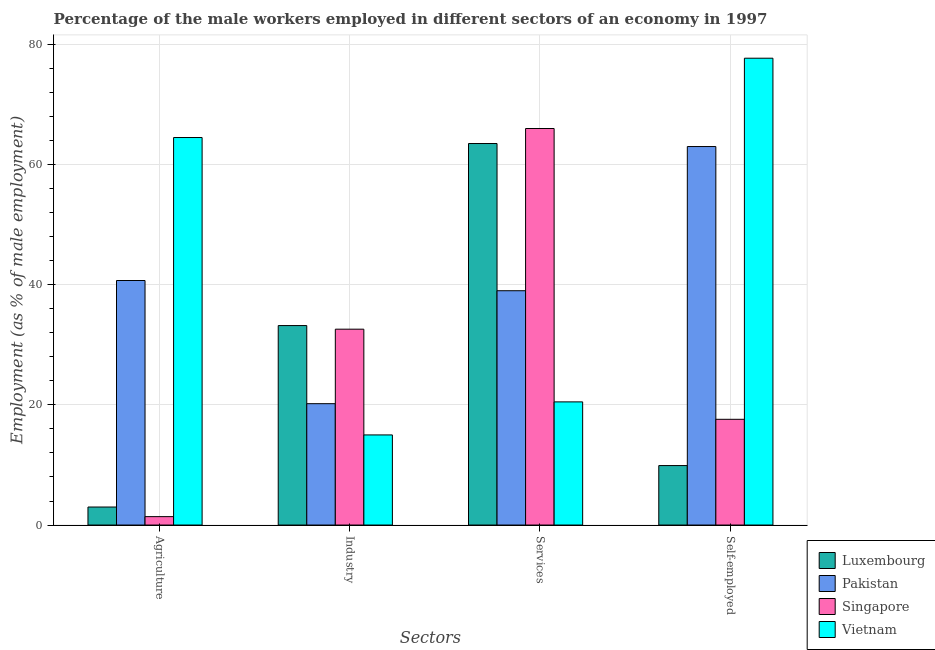How many different coloured bars are there?
Your answer should be very brief. 4. Are the number of bars on each tick of the X-axis equal?
Offer a very short reply. Yes. How many bars are there on the 3rd tick from the left?
Keep it short and to the point. 4. How many bars are there on the 1st tick from the right?
Your response must be concise. 4. What is the label of the 1st group of bars from the left?
Make the answer very short. Agriculture. Across all countries, what is the maximum percentage of male workers in agriculture?
Your answer should be very brief. 64.5. In which country was the percentage of male workers in agriculture maximum?
Offer a very short reply. Vietnam. In which country was the percentage of self employed male workers minimum?
Ensure brevity in your answer.  Luxembourg. What is the total percentage of male workers in industry in the graph?
Your answer should be compact. 101. What is the difference between the percentage of self employed male workers in Luxembourg and the percentage of male workers in services in Pakistan?
Keep it short and to the point. -29.1. What is the average percentage of male workers in services per country?
Give a very brief answer. 47.25. What is the difference between the percentage of male workers in services and percentage of male workers in agriculture in Singapore?
Provide a succinct answer. 64.6. What is the ratio of the percentage of self employed male workers in Vietnam to that in Luxembourg?
Give a very brief answer. 7.85. Is the percentage of self employed male workers in Pakistan less than that in Vietnam?
Your answer should be very brief. Yes. Is the difference between the percentage of male workers in services in Pakistan and Singapore greater than the difference between the percentage of self employed male workers in Pakistan and Singapore?
Ensure brevity in your answer.  No. What is the difference between the highest and the second highest percentage of male workers in agriculture?
Keep it short and to the point. 23.8. What is the difference between the highest and the lowest percentage of male workers in industry?
Your answer should be compact. 18.2. Is it the case that in every country, the sum of the percentage of male workers in agriculture and percentage of male workers in services is greater than the sum of percentage of male workers in industry and percentage of self employed male workers?
Your response must be concise. No. What does the 2nd bar from the left in Services represents?
Provide a succinct answer. Pakistan. What does the 1st bar from the right in Industry represents?
Offer a very short reply. Vietnam. Are all the bars in the graph horizontal?
Your answer should be compact. No. How many countries are there in the graph?
Give a very brief answer. 4. What is the difference between two consecutive major ticks on the Y-axis?
Make the answer very short. 20. Are the values on the major ticks of Y-axis written in scientific E-notation?
Provide a succinct answer. No. Does the graph contain any zero values?
Your answer should be very brief. No. Does the graph contain grids?
Offer a terse response. Yes. How many legend labels are there?
Give a very brief answer. 4. How are the legend labels stacked?
Provide a short and direct response. Vertical. What is the title of the graph?
Ensure brevity in your answer.  Percentage of the male workers employed in different sectors of an economy in 1997. What is the label or title of the X-axis?
Provide a succinct answer. Sectors. What is the label or title of the Y-axis?
Ensure brevity in your answer.  Employment (as % of male employment). What is the Employment (as % of male employment) of Luxembourg in Agriculture?
Your response must be concise. 3. What is the Employment (as % of male employment) in Pakistan in Agriculture?
Provide a succinct answer. 40.7. What is the Employment (as % of male employment) in Singapore in Agriculture?
Provide a succinct answer. 1.4. What is the Employment (as % of male employment) of Vietnam in Agriculture?
Provide a short and direct response. 64.5. What is the Employment (as % of male employment) in Luxembourg in Industry?
Your answer should be compact. 33.2. What is the Employment (as % of male employment) of Pakistan in Industry?
Offer a very short reply. 20.2. What is the Employment (as % of male employment) of Singapore in Industry?
Give a very brief answer. 32.6. What is the Employment (as % of male employment) in Vietnam in Industry?
Your response must be concise. 15. What is the Employment (as % of male employment) of Luxembourg in Services?
Offer a terse response. 63.5. What is the Employment (as % of male employment) in Pakistan in Services?
Offer a terse response. 39. What is the Employment (as % of male employment) of Vietnam in Services?
Offer a terse response. 20.5. What is the Employment (as % of male employment) of Luxembourg in Self-employed?
Keep it short and to the point. 9.9. What is the Employment (as % of male employment) of Pakistan in Self-employed?
Your answer should be very brief. 63. What is the Employment (as % of male employment) of Singapore in Self-employed?
Give a very brief answer. 17.6. What is the Employment (as % of male employment) of Vietnam in Self-employed?
Ensure brevity in your answer.  77.7. Across all Sectors, what is the maximum Employment (as % of male employment) of Luxembourg?
Make the answer very short. 63.5. Across all Sectors, what is the maximum Employment (as % of male employment) of Pakistan?
Your response must be concise. 63. Across all Sectors, what is the maximum Employment (as % of male employment) in Vietnam?
Provide a succinct answer. 77.7. Across all Sectors, what is the minimum Employment (as % of male employment) in Pakistan?
Provide a short and direct response. 20.2. Across all Sectors, what is the minimum Employment (as % of male employment) in Singapore?
Your answer should be compact. 1.4. Across all Sectors, what is the minimum Employment (as % of male employment) of Vietnam?
Provide a short and direct response. 15. What is the total Employment (as % of male employment) of Luxembourg in the graph?
Your response must be concise. 109.6. What is the total Employment (as % of male employment) in Pakistan in the graph?
Your answer should be compact. 162.9. What is the total Employment (as % of male employment) in Singapore in the graph?
Offer a very short reply. 117.6. What is the total Employment (as % of male employment) of Vietnam in the graph?
Offer a very short reply. 177.7. What is the difference between the Employment (as % of male employment) in Luxembourg in Agriculture and that in Industry?
Keep it short and to the point. -30.2. What is the difference between the Employment (as % of male employment) in Pakistan in Agriculture and that in Industry?
Your answer should be compact. 20.5. What is the difference between the Employment (as % of male employment) in Singapore in Agriculture and that in Industry?
Ensure brevity in your answer.  -31.2. What is the difference between the Employment (as % of male employment) in Vietnam in Agriculture and that in Industry?
Make the answer very short. 49.5. What is the difference between the Employment (as % of male employment) of Luxembourg in Agriculture and that in Services?
Your answer should be very brief. -60.5. What is the difference between the Employment (as % of male employment) of Pakistan in Agriculture and that in Services?
Give a very brief answer. 1.7. What is the difference between the Employment (as % of male employment) in Singapore in Agriculture and that in Services?
Give a very brief answer. -64.6. What is the difference between the Employment (as % of male employment) of Pakistan in Agriculture and that in Self-employed?
Your answer should be very brief. -22.3. What is the difference between the Employment (as % of male employment) in Singapore in Agriculture and that in Self-employed?
Your answer should be compact. -16.2. What is the difference between the Employment (as % of male employment) in Luxembourg in Industry and that in Services?
Provide a succinct answer. -30.3. What is the difference between the Employment (as % of male employment) of Pakistan in Industry and that in Services?
Provide a succinct answer. -18.8. What is the difference between the Employment (as % of male employment) in Singapore in Industry and that in Services?
Offer a very short reply. -33.4. What is the difference between the Employment (as % of male employment) in Luxembourg in Industry and that in Self-employed?
Your response must be concise. 23.3. What is the difference between the Employment (as % of male employment) in Pakistan in Industry and that in Self-employed?
Ensure brevity in your answer.  -42.8. What is the difference between the Employment (as % of male employment) in Singapore in Industry and that in Self-employed?
Offer a very short reply. 15. What is the difference between the Employment (as % of male employment) in Vietnam in Industry and that in Self-employed?
Offer a very short reply. -62.7. What is the difference between the Employment (as % of male employment) in Luxembourg in Services and that in Self-employed?
Offer a very short reply. 53.6. What is the difference between the Employment (as % of male employment) of Singapore in Services and that in Self-employed?
Provide a succinct answer. 48.4. What is the difference between the Employment (as % of male employment) of Vietnam in Services and that in Self-employed?
Provide a short and direct response. -57.2. What is the difference between the Employment (as % of male employment) in Luxembourg in Agriculture and the Employment (as % of male employment) in Pakistan in Industry?
Give a very brief answer. -17.2. What is the difference between the Employment (as % of male employment) in Luxembourg in Agriculture and the Employment (as % of male employment) in Singapore in Industry?
Your answer should be very brief. -29.6. What is the difference between the Employment (as % of male employment) of Luxembourg in Agriculture and the Employment (as % of male employment) of Vietnam in Industry?
Make the answer very short. -12. What is the difference between the Employment (as % of male employment) in Pakistan in Agriculture and the Employment (as % of male employment) in Singapore in Industry?
Keep it short and to the point. 8.1. What is the difference between the Employment (as % of male employment) of Pakistan in Agriculture and the Employment (as % of male employment) of Vietnam in Industry?
Provide a short and direct response. 25.7. What is the difference between the Employment (as % of male employment) of Singapore in Agriculture and the Employment (as % of male employment) of Vietnam in Industry?
Offer a terse response. -13.6. What is the difference between the Employment (as % of male employment) in Luxembourg in Agriculture and the Employment (as % of male employment) in Pakistan in Services?
Provide a succinct answer. -36. What is the difference between the Employment (as % of male employment) in Luxembourg in Agriculture and the Employment (as % of male employment) in Singapore in Services?
Ensure brevity in your answer.  -63. What is the difference between the Employment (as % of male employment) of Luxembourg in Agriculture and the Employment (as % of male employment) of Vietnam in Services?
Offer a very short reply. -17.5. What is the difference between the Employment (as % of male employment) of Pakistan in Agriculture and the Employment (as % of male employment) of Singapore in Services?
Keep it short and to the point. -25.3. What is the difference between the Employment (as % of male employment) in Pakistan in Agriculture and the Employment (as % of male employment) in Vietnam in Services?
Your answer should be very brief. 20.2. What is the difference between the Employment (as % of male employment) of Singapore in Agriculture and the Employment (as % of male employment) of Vietnam in Services?
Your response must be concise. -19.1. What is the difference between the Employment (as % of male employment) of Luxembourg in Agriculture and the Employment (as % of male employment) of Pakistan in Self-employed?
Offer a terse response. -60. What is the difference between the Employment (as % of male employment) in Luxembourg in Agriculture and the Employment (as % of male employment) in Singapore in Self-employed?
Your answer should be compact. -14.6. What is the difference between the Employment (as % of male employment) of Luxembourg in Agriculture and the Employment (as % of male employment) of Vietnam in Self-employed?
Your answer should be compact. -74.7. What is the difference between the Employment (as % of male employment) of Pakistan in Agriculture and the Employment (as % of male employment) of Singapore in Self-employed?
Give a very brief answer. 23.1. What is the difference between the Employment (as % of male employment) of Pakistan in Agriculture and the Employment (as % of male employment) of Vietnam in Self-employed?
Provide a succinct answer. -37. What is the difference between the Employment (as % of male employment) in Singapore in Agriculture and the Employment (as % of male employment) in Vietnam in Self-employed?
Your answer should be very brief. -76.3. What is the difference between the Employment (as % of male employment) of Luxembourg in Industry and the Employment (as % of male employment) of Pakistan in Services?
Keep it short and to the point. -5.8. What is the difference between the Employment (as % of male employment) in Luxembourg in Industry and the Employment (as % of male employment) in Singapore in Services?
Make the answer very short. -32.8. What is the difference between the Employment (as % of male employment) in Luxembourg in Industry and the Employment (as % of male employment) in Vietnam in Services?
Your answer should be very brief. 12.7. What is the difference between the Employment (as % of male employment) of Pakistan in Industry and the Employment (as % of male employment) of Singapore in Services?
Give a very brief answer. -45.8. What is the difference between the Employment (as % of male employment) of Singapore in Industry and the Employment (as % of male employment) of Vietnam in Services?
Your response must be concise. 12.1. What is the difference between the Employment (as % of male employment) of Luxembourg in Industry and the Employment (as % of male employment) of Pakistan in Self-employed?
Provide a succinct answer. -29.8. What is the difference between the Employment (as % of male employment) of Luxembourg in Industry and the Employment (as % of male employment) of Vietnam in Self-employed?
Your answer should be compact. -44.5. What is the difference between the Employment (as % of male employment) of Pakistan in Industry and the Employment (as % of male employment) of Singapore in Self-employed?
Provide a short and direct response. 2.6. What is the difference between the Employment (as % of male employment) of Pakistan in Industry and the Employment (as % of male employment) of Vietnam in Self-employed?
Offer a terse response. -57.5. What is the difference between the Employment (as % of male employment) of Singapore in Industry and the Employment (as % of male employment) of Vietnam in Self-employed?
Offer a very short reply. -45.1. What is the difference between the Employment (as % of male employment) in Luxembourg in Services and the Employment (as % of male employment) in Singapore in Self-employed?
Provide a succinct answer. 45.9. What is the difference between the Employment (as % of male employment) of Pakistan in Services and the Employment (as % of male employment) of Singapore in Self-employed?
Your response must be concise. 21.4. What is the difference between the Employment (as % of male employment) in Pakistan in Services and the Employment (as % of male employment) in Vietnam in Self-employed?
Offer a terse response. -38.7. What is the average Employment (as % of male employment) of Luxembourg per Sectors?
Give a very brief answer. 27.4. What is the average Employment (as % of male employment) of Pakistan per Sectors?
Offer a very short reply. 40.73. What is the average Employment (as % of male employment) of Singapore per Sectors?
Make the answer very short. 29.4. What is the average Employment (as % of male employment) in Vietnam per Sectors?
Provide a short and direct response. 44.42. What is the difference between the Employment (as % of male employment) in Luxembourg and Employment (as % of male employment) in Pakistan in Agriculture?
Your answer should be compact. -37.7. What is the difference between the Employment (as % of male employment) in Luxembourg and Employment (as % of male employment) in Vietnam in Agriculture?
Offer a very short reply. -61.5. What is the difference between the Employment (as % of male employment) in Pakistan and Employment (as % of male employment) in Singapore in Agriculture?
Keep it short and to the point. 39.3. What is the difference between the Employment (as % of male employment) of Pakistan and Employment (as % of male employment) of Vietnam in Agriculture?
Offer a very short reply. -23.8. What is the difference between the Employment (as % of male employment) of Singapore and Employment (as % of male employment) of Vietnam in Agriculture?
Offer a terse response. -63.1. What is the difference between the Employment (as % of male employment) in Luxembourg and Employment (as % of male employment) in Singapore in Industry?
Give a very brief answer. 0.6. What is the difference between the Employment (as % of male employment) in Luxembourg and Employment (as % of male employment) in Vietnam in Industry?
Provide a succinct answer. 18.2. What is the difference between the Employment (as % of male employment) of Pakistan and Employment (as % of male employment) of Vietnam in Industry?
Make the answer very short. 5.2. What is the difference between the Employment (as % of male employment) in Luxembourg and Employment (as % of male employment) in Pakistan in Services?
Your response must be concise. 24.5. What is the difference between the Employment (as % of male employment) of Pakistan and Employment (as % of male employment) of Vietnam in Services?
Offer a terse response. 18.5. What is the difference between the Employment (as % of male employment) of Singapore and Employment (as % of male employment) of Vietnam in Services?
Give a very brief answer. 45.5. What is the difference between the Employment (as % of male employment) in Luxembourg and Employment (as % of male employment) in Pakistan in Self-employed?
Your answer should be very brief. -53.1. What is the difference between the Employment (as % of male employment) in Luxembourg and Employment (as % of male employment) in Vietnam in Self-employed?
Provide a succinct answer. -67.8. What is the difference between the Employment (as % of male employment) in Pakistan and Employment (as % of male employment) in Singapore in Self-employed?
Your answer should be compact. 45.4. What is the difference between the Employment (as % of male employment) of Pakistan and Employment (as % of male employment) of Vietnam in Self-employed?
Offer a very short reply. -14.7. What is the difference between the Employment (as % of male employment) of Singapore and Employment (as % of male employment) of Vietnam in Self-employed?
Make the answer very short. -60.1. What is the ratio of the Employment (as % of male employment) of Luxembourg in Agriculture to that in Industry?
Provide a succinct answer. 0.09. What is the ratio of the Employment (as % of male employment) in Pakistan in Agriculture to that in Industry?
Make the answer very short. 2.01. What is the ratio of the Employment (as % of male employment) of Singapore in Agriculture to that in Industry?
Make the answer very short. 0.04. What is the ratio of the Employment (as % of male employment) of Luxembourg in Agriculture to that in Services?
Give a very brief answer. 0.05. What is the ratio of the Employment (as % of male employment) of Pakistan in Agriculture to that in Services?
Provide a succinct answer. 1.04. What is the ratio of the Employment (as % of male employment) of Singapore in Agriculture to that in Services?
Provide a short and direct response. 0.02. What is the ratio of the Employment (as % of male employment) of Vietnam in Agriculture to that in Services?
Ensure brevity in your answer.  3.15. What is the ratio of the Employment (as % of male employment) in Luxembourg in Agriculture to that in Self-employed?
Provide a succinct answer. 0.3. What is the ratio of the Employment (as % of male employment) in Pakistan in Agriculture to that in Self-employed?
Your answer should be very brief. 0.65. What is the ratio of the Employment (as % of male employment) of Singapore in Agriculture to that in Self-employed?
Your answer should be compact. 0.08. What is the ratio of the Employment (as % of male employment) of Vietnam in Agriculture to that in Self-employed?
Offer a very short reply. 0.83. What is the ratio of the Employment (as % of male employment) in Luxembourg in Industry to that in Services?
Your response must be concise. 0.52. What is the ratio of the Employment (as % of male employment) in Pakistan in Industry to that in Services?
Provide a succinct answer. 0.52. What is the ratio of the Employment (as % of male employment) of Singapore in Industry to that in Services?
Make the answer very short. 0.49. What is the ratio of the Employment (as % of male employment) of Vietnam in Industry to that in Services?
Your answer should be very brief. 0.73. What is the ratio of the Employment (as % of male employment) in Luxembourg in Industry to that in Self-employed?
Offer a very short reply. 3.35. What is the ratio of the Employment (as % of male employment) in Pakistan in Industry to that in Self-employed?
Your response must be concise. 0.32. What is the ratio of the Employment (as % of male employment) of Singapore in Industry to that in Self-employed?
Make the answer very short. 1.85. What is the ratio of the Employment (as % of male employment) in Vietnam in Industry to that in Self-employed?
Offer a terse response. 0.19. What is the ratio of the Employment (as % of male employment) of Luxembourg in Services to that in Self-employed?
Provide a succinct answer. 6.41. What is the ratio of the Employment (as % of male employment) in Pakistan in Services to that in Self-employed?
Provide a succinct answer. 0.62. What is the ratio of the Employment (as % of male employment) of Singapore in Services to that in Self-employed?
Your response must be concise. 3.75. What is the ratio of the Employment (as % of male employment) in Vietnam in Services to that in Self-employed?
Your answer should be compact. 0.26. What is the difference between the highest and the second highest Employment (as % of male employment) of Luxembourg?
Ensure brevity in your answer.  30.3. What is the difference between the highest and the second highest Employment (as % of male employment) in Pakistan?
Keep it short and to the point. 22.3. What is the difference between the highest and the second highest Employment (as % of male employment) of Singapore?
Ensure brevity in your answer.  33.4. What is the difference between the highest and the second highest Employment (as % of male employment) in Vietnam?
Give a very brief answer. 13.2. What is the difference between the highest and the lowest Employment (as % of male employment) in Luxembourg?
Make the answer very short. 60.5. What is the difference between the highest and the lowest Employment (as % of male employment) of Pakistan?
Give a very brief answer. 42.8. What is the difference between the highest and the lowest Employment (as % of male employment) in Singapore?
Offer a terse response. 64.6. What is the difference between the highest and the lowest Employment (as % of male employment) in Vietnam?
Provide a succinct answer. 62.7. 